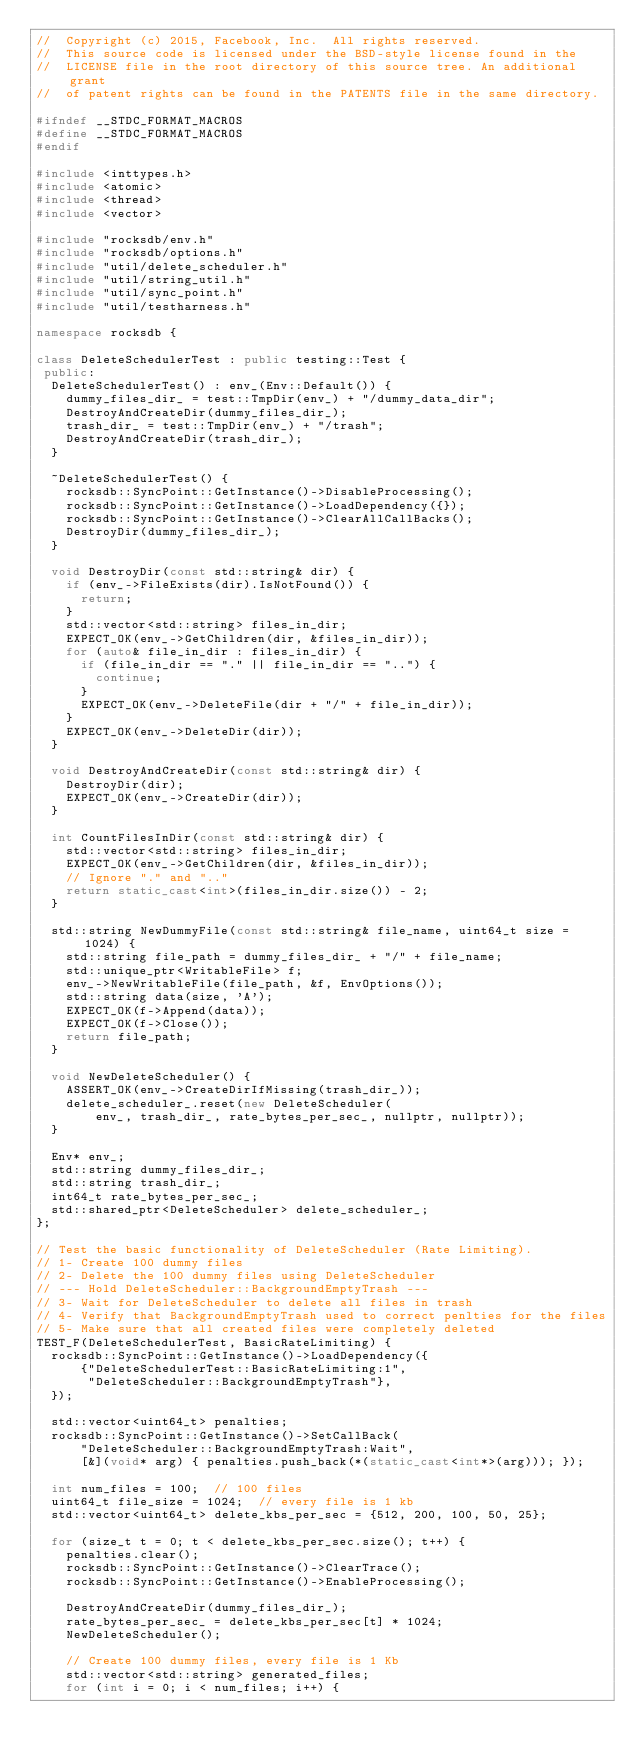<code> <loc_0><loc_0><loc_500><loc_500><_C++_>//  Copyright (c) 2015, Facebook, Inc.  All rights reserved.
//  This source code is licensed under the BSD-style license found in the
//  LICENSE file in the root directory of this source tree. An additional grant
//  of patent rights can be found in the PATENTS file in the same directory.

#ifndef __STDC_FORMAT_MACROS
#define __STDC_FORMAT_MACROS
#endif

#include <inttypes.h>
#include <atomic>
#include <thread>
#include <vector>

#include "rocksdb/env.h"
#include "rocksdb/options.h"
#include "util/delete_scheduler.h"
#include "util/string_util.h"
#include "util/sync_point.h"
#include "util/testharness.h"

namespace rocksdb {

class DeleteSchedulerTest : public testing::Test {
 public:
  DeleteSchedulerTest() : env_(Env::Default()) {
    dummy_files_dir_ = test::TmpDir(env_) + "/dummy_data_dir";
    DestroyAndCreateDir(dummy_files_dir_);
    trash_dir_ = test::TmpDir(env_) + "/trash";
    DestroyAndCreateDir(trash_dir_);
  }

  ~DeleteSchedulerTest() {
    rocksdb::SyncPoint::GetInstance()->DisableProcessing();
    rocksdb::SyncPoint::GetInstance()->LoadDependency({});
    rocksdb::SyncPoint::GetInstance()->ClearAllCallBacks();
    DestroyDir(dummy_files_dir_);
  }

  void DestroyDir(const std::string& dir) {
    if (env_->FileExists(dir).IsNotFound()) {
      return;
    }
    std::vector<std::string> files_in_dir;
    EXPECT_OK(env_->GetChildren(dir, &files_in_dir));
    for (auto& file_in_dir : files_in_dir) {
      if (file_in_dir == "." || file_in_dir == "..") {
        continue;
      }
      EXPECT_OK(env_->DeleteFile(dir + "/" + file_in_dir));
    }
    EXPECT_OK(env_->DeleteDir(dir));
  }

  void DestroyAndCreateDir(const std::string& dir) {
    DestroyDir(dir);
    EXPECT_OK(env_->CreateDir(dir));
  }

  int CountFilesInDir(const std::string& dir) {
    std::vector<std::string> files_in_dir;
    EXPECT_OK(env_->GetChildren(dir, &files_in_dir));
    // Ignore "." and ".."
    return static_cast<int>(files_in_dir.size()) - 2;
  }

  std::string NewDummyFile(const std::string& file_name, uint64_t size = 1024) {
    std::string file_path = dummy_files_dir_ + "/" + file_name;
    std::unique_ptr<WritableFile> f;
    env_->NewWritableFile(file_path, &f, EnvOptions());
    std::string data(size, 'A');
    EXPECT_OK(f->Append(data));
    EXPECT_OK(f->Close());
    return file_path;
  }

  void NewDeleteScheduler() {
    ASSERT_OK(env_->CreateDirIfMissing(trash_dir_));
    delete_scheduler_.reset(new DeleteScheduler(
        env_, trash_dir_, rate_bytes_per_sec_, nullptr, nullptr));
  }

  Env* env_;
  std::string dummy_files_dir_;
  std::string trash_dir_;
  int64_t rate_bytes_per_sec_;
  std::shared_ptr<DeleteScheduler> delete_scheduler_;
};

// Test the basic functionality of DeleteScheduler (Rate Limiting).
// 1- Create 100 dummy files
// 2- Delete the 100 dummy files using DeleteScheduler
// --- Hold DeleteScheduler::BackgroundEmptyTrash ---
// 3- Wait for DeleteScheduler to delete all files in trash
// 4- Verify that BackgroundEmptyTrash used to correct penlties for the files
// 5- Make sure that all created files were completely deleted
TEST_F(DeleteSchedulerTest, BasicRateLimiting) {
  rocksdb::SyncPoint::GetInstance()->LoadDependency({
      {"DeleteSchedulerTest::BasicRateLimiting:1",
       "DeleteScheduler::BackgroundEmptyTrash"},
  });

  std::vector<uint64_t> penalties;
  rocksdb::SyncPoint::GetInstance()->SetCallBack(
      "DeleteScheduler::BackgroundEmptyTrash:Wait",
      [&](void* arg) { penalties.push_back(*(static_cast<int*>(arg))); });

  int num_files = 100;  // 100 files
  uint64_t file_size = 1024;  // every file is 1 kb
  std::vector<uint64_t> delete_kbs_per_sec = {512, 200, 100, 50, 25};

  for (size_t t = 0; t < delete_kbs_per_sec.size(); t++) {
    penalties.clear();
    rocksdb::SyncPoint::GetInstance()->ClearTrace();
    rocksdb::SyncPoint::GetInstance()->EnableProcessing();

    DestroyAndCreateDir(dummy_files_dir_);
    rate_bytes_per_sec_ = delete_kbs_per_sec[t] * 1024;
    NewDeleteScheduler();

    // Create 100 dummy files, every file is 1 Kb
    std::vector<std::string> generated_files;
    for (int i = 0; i < num_files; i++) {</code> 